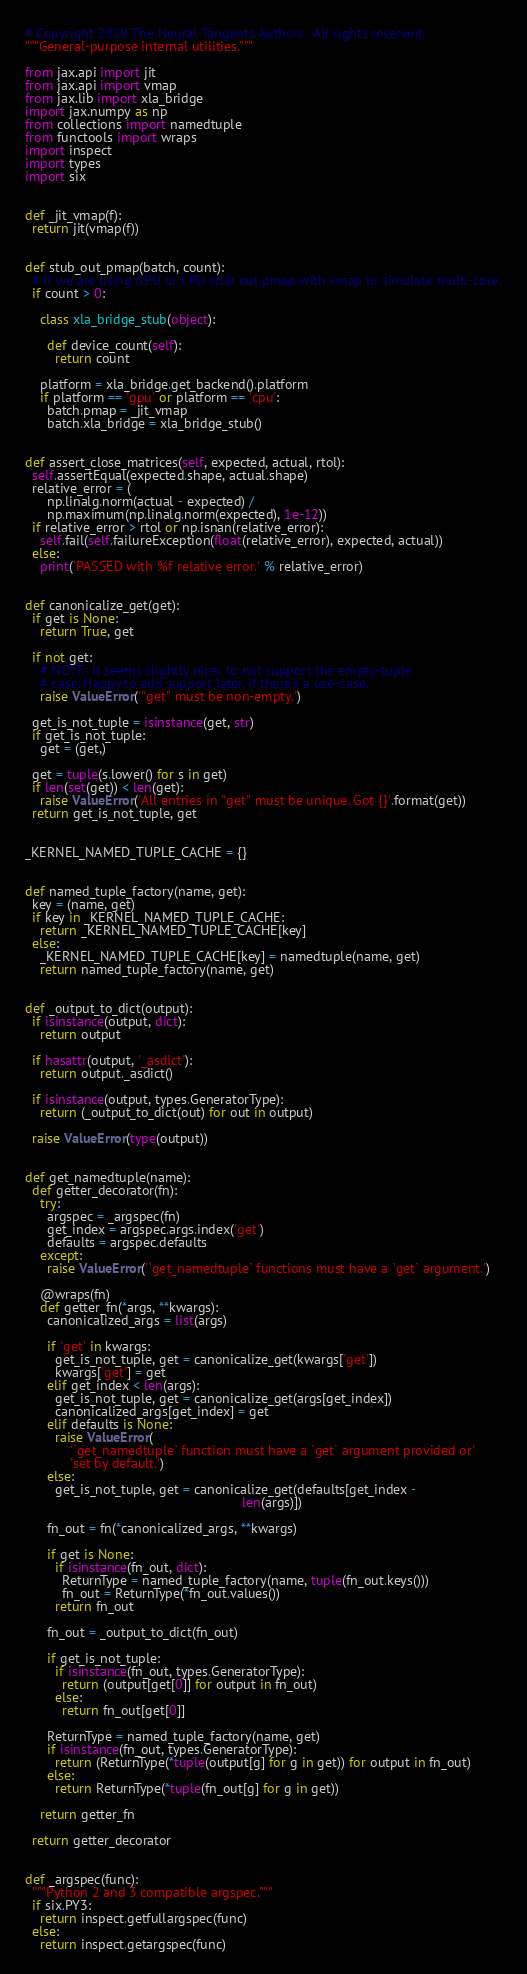<code> <loc_0><loc_0><loc_500><loc_500><_Python_># Copyright 2019 The Neural Tangents Authors.  All rights reserved.
"""General-purpose internal utilities."""

from jax.api import jit
from jax.api import vmap
from jax.lib import xla_bridge
import jax.numpy as np
from collections import namedtuple
from functools import wraps
import inspect
import types
import six


def _jit_vmap(f):
  return jit(vmap(f))


def stub_out_pmap(batch, count):
  # If we are using GPU or CPU stub out pmap with vmap to simulate multi-core.
  if count > 0:

    class xla_bridge_stub(object):

      def device_count(self):
        return count

    platform = xla_bridge.get_backend().platform
    if platform == 'gpu' or platform == 'cpu':
      batch.pmap = _jit_vmap
      batch.xla_bridge = xla_bridge_stub()


def assert_close_matrices(self, expected, actual, rtol):
  self.assertEqual(expected.shape, actual.shape)
  relative_error = (
      np.linalg.norm(actual - expected) /
      np.maximum(np.linalg.norm(expected), 1e-12))
  if relative_error > rtol or np.isnan(relative_error):
    self.fail(self.failureException(float(relative_error), expected, actual))
  else:
    print('PASSED with %f relative error.' % relative_error)


def canonicalize_get(get):
  if get is None:
    return True, get

  if not get:
    # NOTE: It seems slightly nicer to not support the empty-tuple
    # case. Happy to add support later, if there's a use-case.
    raise ValueError('"get" must be non-empty.')

  get_is_not_tuple = isinstance(get, str)
  if get_is_not_tuple:
    get = (get,)

  get = tuple(s.lower() for s in get)
  if len(set(get)) < len(get):
    raise ValueError('All entries in "get" must be unique. Got {}'.format(get))
  return get_is_not_tuple, get


_KERNEL_NAMED_TUPLE_CACHE = {}


def named_tuple_factory(name, get):
  key = (name, get)
  if key in _KERNEL_NAMED_TUPLE_CACHE:
    return _KERNEL_NAMED_TUPLE_CACHE[key]
  else:
    _KERNEL_NAMED_TUPLE_CACHE[key] = namedtuple(name, get)
    return named_tuple_factory(name, get)


def _output_to_dict(output):
  if isinstance(output, dict):
    return output

  if hasattr(output, '_asdict'):
    return output._asdict()

  if isinstance(output, types.GeneratorType):
    return (_output_to_dict(out) for out in output)

  raise ValueError(type(output))


def get_namedtuple(name):
  def getter_decorator(fn):
    try:
      argspec = _argspec(fn)
      get_index = argspec.args.index('get')
      defaults = argspec.defaults
    except:
      raise ValueError('`get_namedtuple` functions must have a `get` argument.')

    @wraps(fn)
    def getter_fn(*args, **kwargs):
      canonicalized_args = list(args)

      if 'get' in kwargs:
        get_is_not_tuple, get = canonicalize_get(kwargs['get'])
        kwargs['get'] = get
      elif get_index < len(args):
        get_is_not_tuple, get = canonicalize_get(args[get_index])
        canonicalized_args[get_index] = get
      elif defaults is None:
        raise ValueError(
            '`get_namedtuple` function must have a `get` argument provided or'
            'set by default.')
      else:
        get_is_not_tuple, get = canonicalize_get(defaults[get_index -
                                                          len(args)])

      fn_out = fn(*canonicalized_args, **kwargs)

      if get is None:
        if isinstance(fn_out, dict):
          ReturnType = named_tuple_factory(name, tuple(fn_out.keys()))
          fn_out = ReturnType(*fn_out.values())
        return fn_out

      fn_out = _output_to_dict(fn_out)

      if get_is_not_tuple:
        if isinstance(fn_out, types.GeneratorType):
          return (output[get[0]] for output in fn_out)
        else:
          return fn_out[get[0]]

      ReturnType = named_tuple_factory(name, get)
      if isinstance(fn_out, types.GeneratorType):
        return (ReturnType(*tuple(output[g] for g in get)) for output in fn_out)
      else:
        return ReturnType(*tuple(fn_out[g] for g in get))

    return getter_fn

  return getter_decorator


def _argspec(func):
  """Python 2 and 3 compatible argspec."""
  if six.PY3:
    return inspect.getfullargspec(func)
  else:
    return inspect.getargspec(func)
</code> 